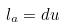Convert formula to latex. <formula><loc_0><loc_0><loc_500><loc_500>l _ { a } = d u</formula> 